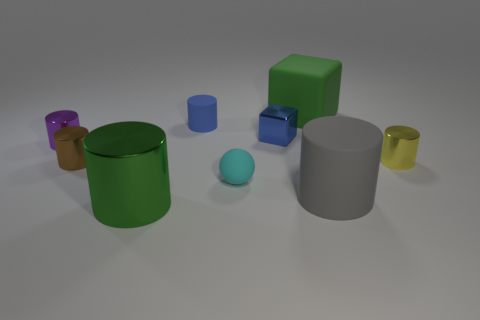There is a green object that is in front of the small purple cylinder; what shape is it?
Your response must be concise. Cylinder. What number of small metallic cylinders are both in front of the small purple metal object and to the left of the big green metal cylinder?
Make the answer very short. 1. What number of other things are the same size as the blue matte thing?
Keep it short and to the point. 5. There is a blue object to the left of the small ball; is it the same shape as the blue metal object that is to the left of the tiny yellow object?
Offer a terse response. No. What number of objects are big gray metal blocks or large matte things in front of the rubber block?
Offer a very short reply. 1. The cylinder that is both right of the small cyan matte object and behind the small brown metal cylinder is made of what material?
Keep it short and to the point. Metal. Is there anything else that is the same shape as the green shiny thing?
Your response must be concise. Yes. What is the color of the big block that is the same material as the sphere?
Provide a succinct answer. Green. What number of objects are small shiny things or small green shiny cylinders?
Give a very brief answer. 4. Does the yellow metallic object have the same size as the block that is in front of the big cube?
Offer a very short reply. Yes. 